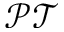<formula> <loc_0><loc_0><loc_500><loc_500>\mathcal { P T }</formula> 